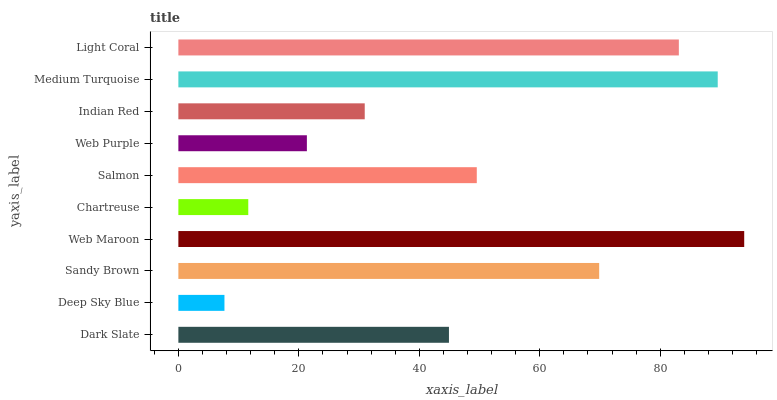Is Deep Sky Blue the minimum?
Answer yes or no. Yes. Is Web Maroon the maximum?
Answer yes or no. Yes. Is Sandy Brown the minimum?
Answer yes or no. No. Is Sandy Brown the maximum?
Answer yes or no. No. Is Sandy Brown greater than Deep Sky Blue?
Answer yes or no. Yes. Is Deep Sky Blue less than Sandy Brown?
Answer yes or no. Yes. Is Deep Sky Blue greater than Sandy Brown?
Answer yes or no. No. Is Sandy Brown less than Deep Sky Blue?
Answer yes or no. No. Is Salmon the high median?
Answer yes or no. Yes. Is Dark Slate the low median?
Answer yes or no. Yes. Is Sandy Brown the high median?
Answer yes or no. No. Is Web Purple the low median?
Answer yes or no. No. 